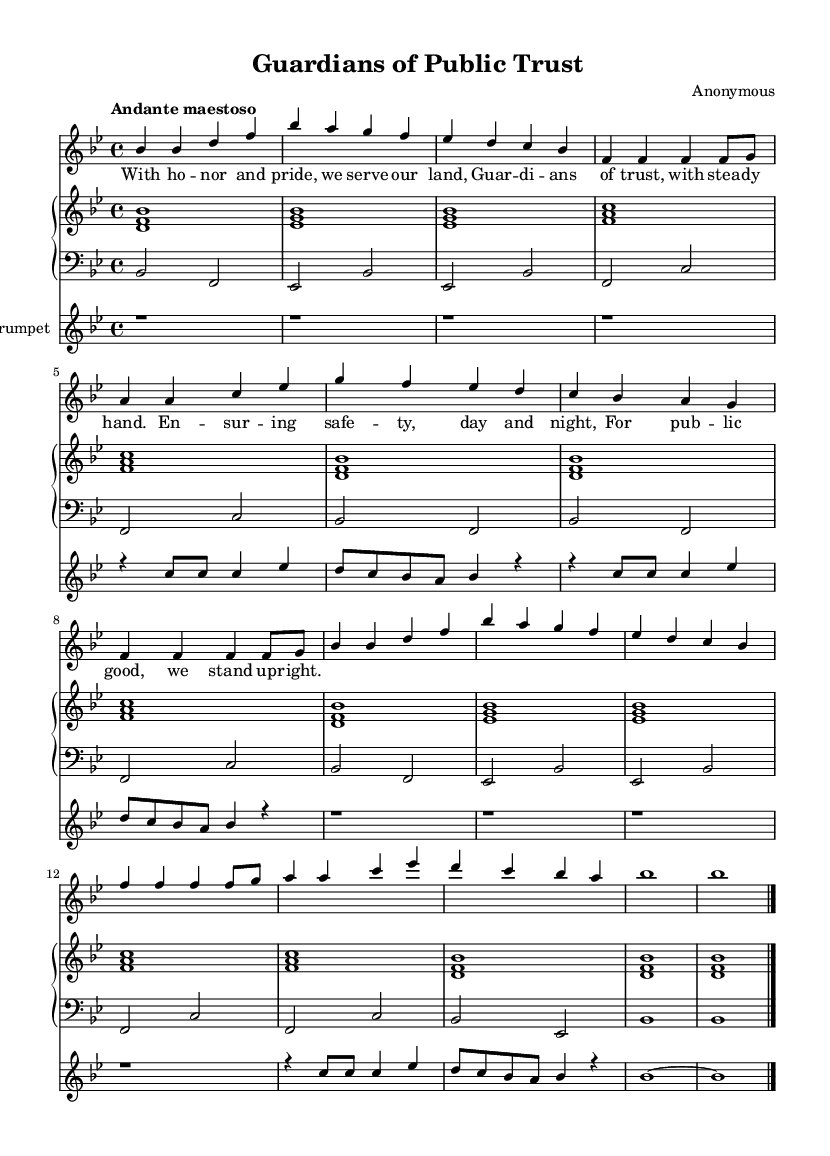What is the key signature of this music? The key signature is indicated at the beginning of the staff, which shows two flat symbols (B and E), indicating that the piece is in B flat major.
Answer: B flat major What is the time signature of this music? The time signature is shown at the beginning of the piece, indicated by the numbers 4 and 4, meaning there are four beats per measure and the quarter note receives one beat.
Answer: 4/4 What is the tempo marking of this music? The tempo marking is at the start of the piece, which states "Andante maestoso," a tempo that typically suggests a moderately slow pace.
Answer: Andante maestoso How many measures are in the piece? By counting the number of groups of vertical lines (bar lines) in the music, we find there are a total of twelve measures in this piece.
Answer: Twelve What instrument does the score include besides the voice? The score includes a piano staff and a trumpet part, indicating that these instruments perform alongside the melody of the voice.
Answer: Piano and trumpet Which phrase contains the lyrics about "public good"? The lyrics "For pub -- lic good, we stand up -- right." directly mention the phrase referring to public good and can be found toward the end of the piece.
Answer: For public good 